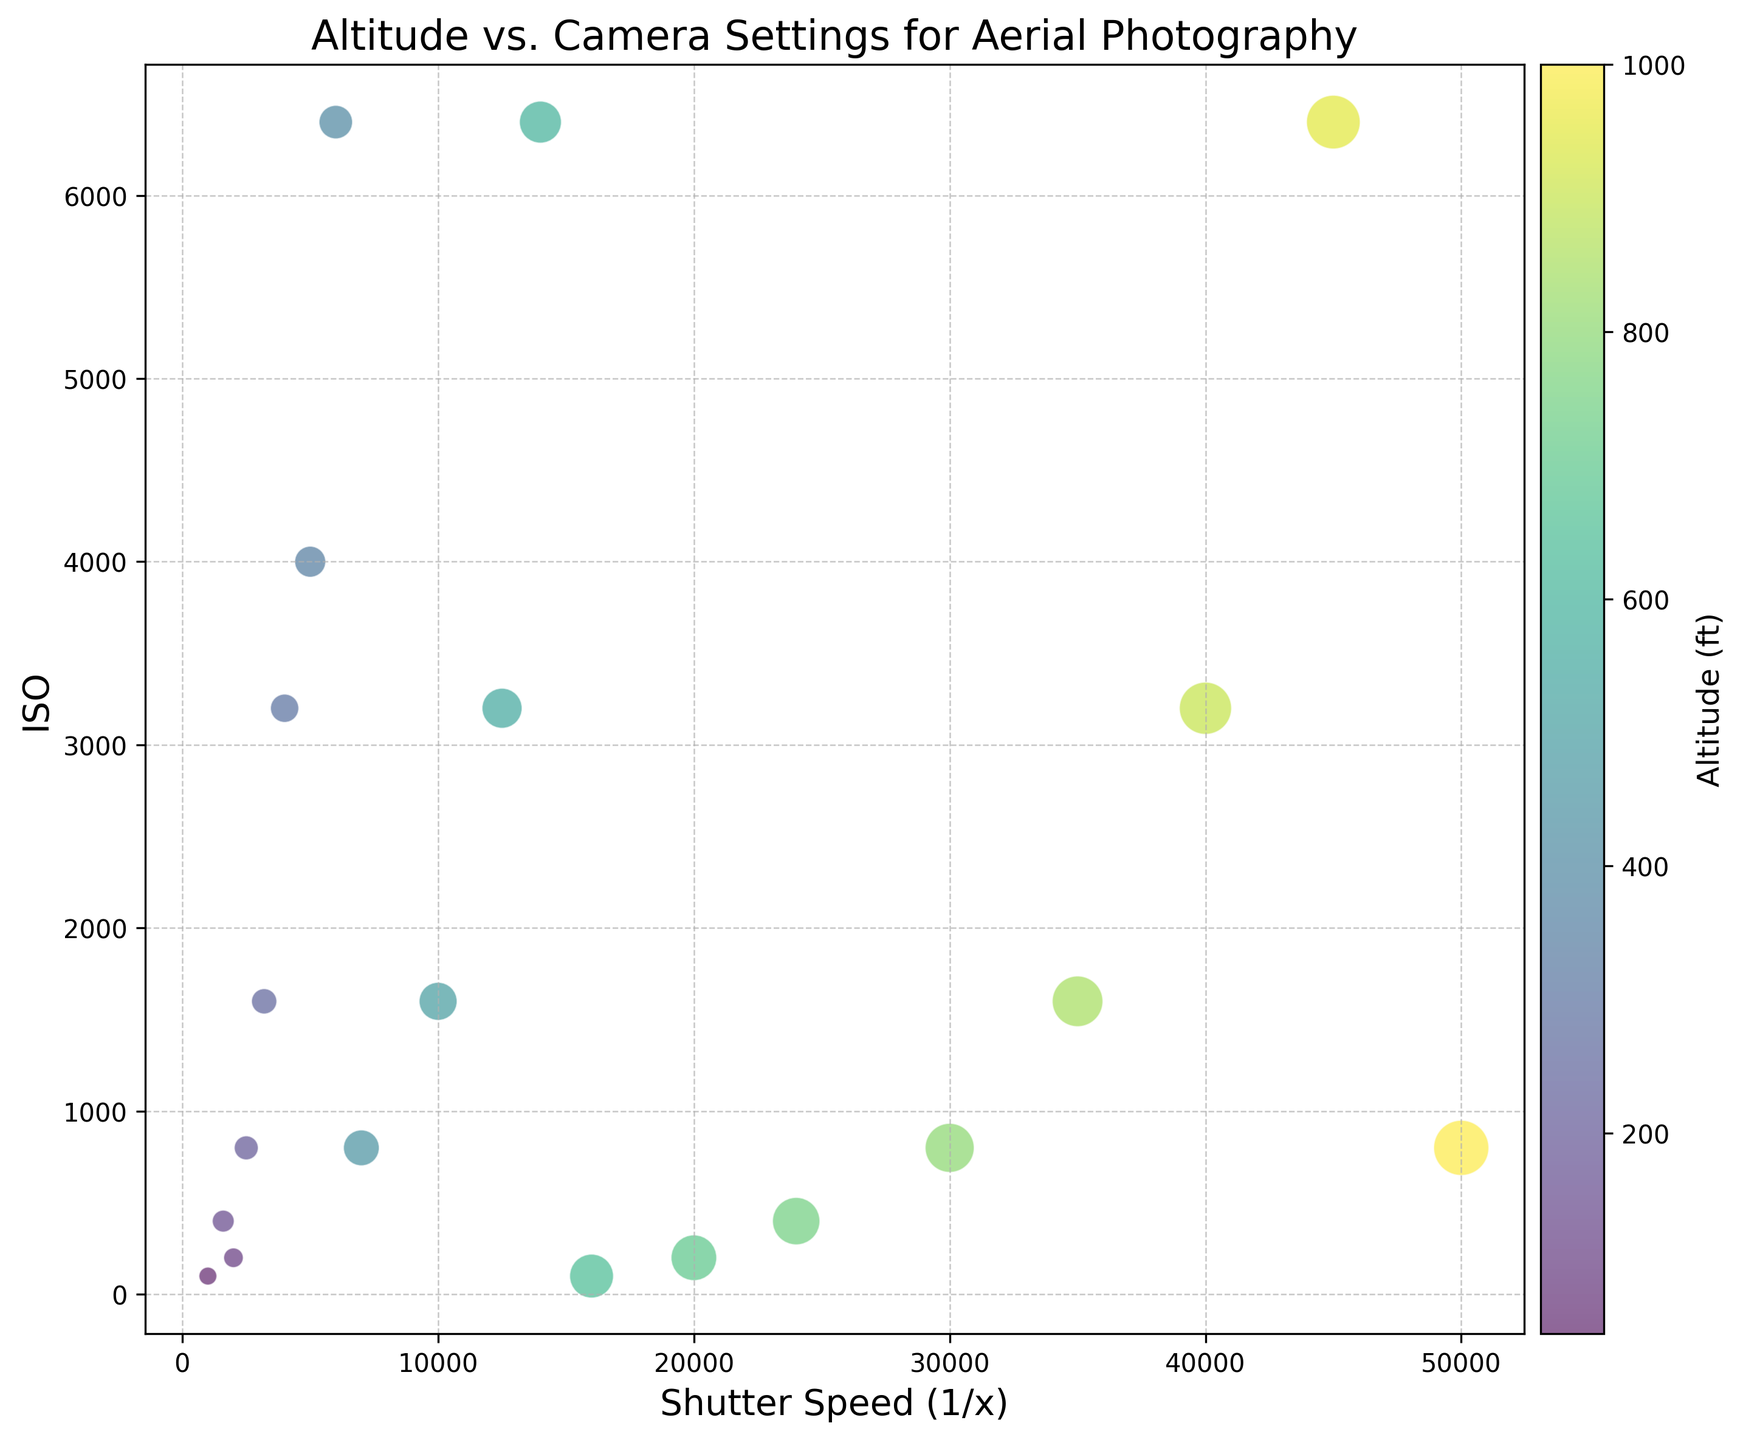what does the color of the bubbles represent? The color of the bubbles represents the altitude at which the photographs were taken. This can be seen from the color bar on the right side of the figure, which maps colors to altitude values.
Answer: Altitude Which data point has the largest bubble size? The largest bubble size corresponds to an altitude of 1000 ft, a shutter speed of 1/50000, and an ISO of 800. You can observe this by looking at the figure and finding the largest bubble and cross-referencing the color gradient.
Answer: Altitude 1000 ft, Shutter Speed 1/50000, ISO 800 What is the general trend between shutter speed and ISO as altitude increases? As altitude increases, both the shutter speed and ISO generally increase. You can observe this by noting that bubbles higher on the altitude color gradient have higher x (shutter speed 1/x) values and higher y (ISO) values.
Answer: Both increase What altitude corresponds to the highest ISO value? The highest ISO value is 6400, which is represented by several data points. By checking the color of these bubbles, you can see that the corresponding altitudes are 400 ft, 600 ft, and 950 ft.
Answer: 400 ft, 600 ft, 950 ft Are there any altitudes where the ISO value is 1600? Yes, there are several data points where the ISO value is 1600. By checking the color and corresponding altitudes of these bubbles, you can see they are at 250 ft, 500 ft, and 850 ft.
Answer: 250 ft, 500 ft, 850 ft Which data point has the fastest shutter speed? The fastest shutter speed is 1/50000, and it corresponds to an altitude of 1000 ft and an ISO of 800. You can see this by locating the furthest data point to the right on the x-axis and checking its corresponding color and size.
Answer: Altitude 1000 ft, ISO 800 